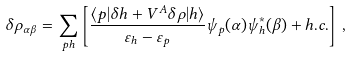Convert formula to latex. <formula><loc_0><loc_0><loc_500><loc_500>\delta \rho _ { \alpha \beta } = \sum _ { p h } \left [ \frac { \langle p | \delta h + V ^ { A } \delta \rho | h \rangle } { \varepsilon _ { h } - \varepsilon _ { p } } \psi _ { p } ( \alpha ) \psi _ { h } ^ { * } ( \beta ) + h . c . \right ] \, ,</formula> 